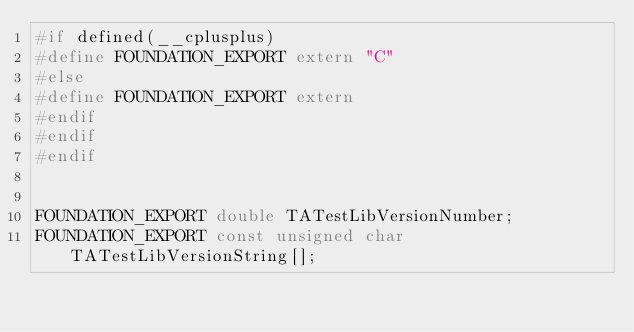<code> <loc_0><loc_0><loc_500><loc_500><_C_>#if defined(__cplusplus)
#define FOUNDATION_EXPORT extern "C"
#else
#define FOUNDATION_EXPORT extern
#endif
#endif
#endif


FOUNDATION_EXPORT double TATestLibVersionNumber;
FOUNDATION_EXPORT const unsigned char TATestLibVersionString[];

</code> 